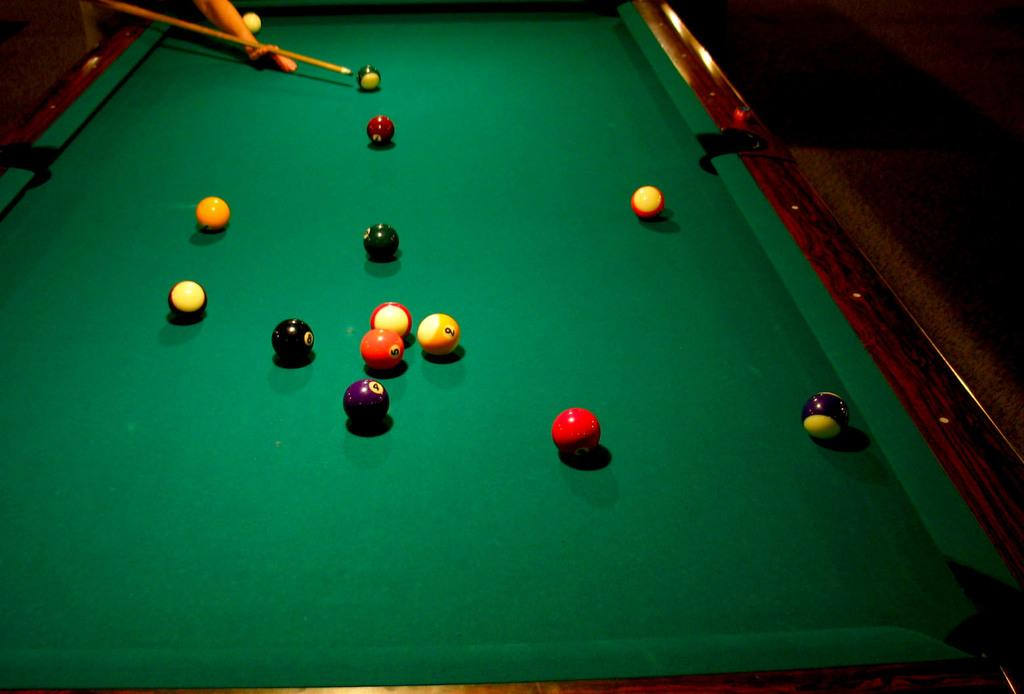What game is being played or prepared for in the image? The image features a snooker board, which suggests that the game of snooker is being played or prepared for. What objects are present on the snooker board? There are balls on the snooker board. What tool is used to hit the balls in the game of snooker? There is a stick (likely a cue) in the image, which is used to hit the balls. What type of trousers are being worn by the snooker balls in the image? The snooker balls do not wear trousers, as they are inanimate objects and not capable of wearing clothing. 